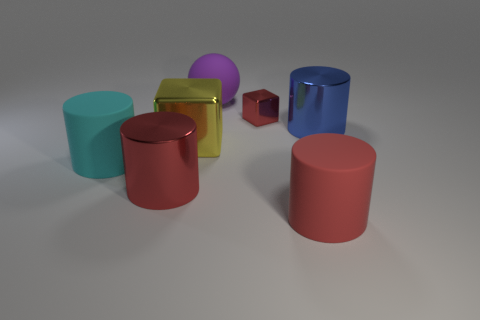How many objects are there in the image and can you describe their shapes? In the image, there are a total of five objects, each with a distinct shape. From left to right, there appears to be a teal cylinder, a yellowish-green cuboid, a violet sphere, a small burgundy cube, and a large burgundy cylinder. 